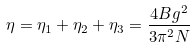<formula> <loc_0><loc_0><loc_500><loc_500>\eta = \eta _ { 1 } + \eta _ { 2 } + \eta _ { 3 } = \frac { 4 B g ^ { 2 } } { 3 \pi ^ { 2 } N }</formula> 